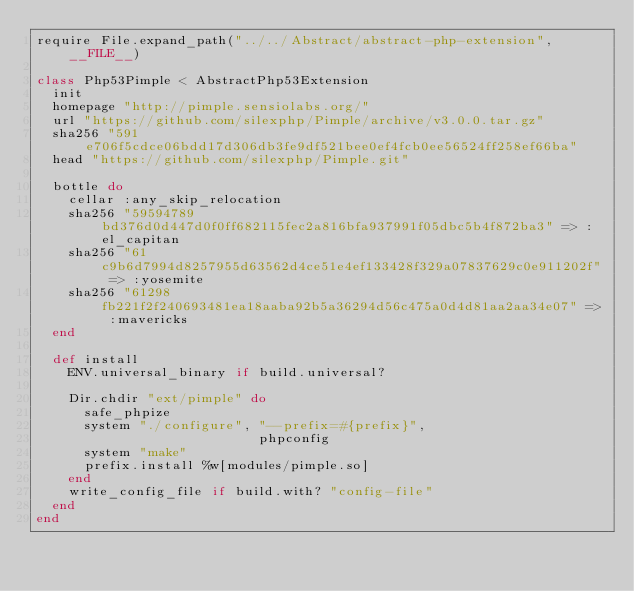<code> <loc_0><loc_0><loc_500><loc_500><_Ruby_>require File.expand_path("../../Abstract/abstract-php-extension", __FILE__)

class Php53Pimple < AbstractPhp53Extension
  init
  homepage "http://pimple.sensiolabs.org/"
  url "https://github.com/silexphp/Pimple/archive/v3.0.0.tar.gz"
  sha256 "591e706f5cdce06bdd17d306db3fe9df521bee0ef4fcb0ee56524ff258ef66ba"
  head "https://github.com/silexphp/Pimple.git"

  bottle do
    cellar :any_skip_relocation
    sha256 "59594789bd376d0d447d0f0ff682115fec2a816bfa937991f05dbc5b4f872ba3" => :el_capitan
    sha256 "61c9b6d7994d8257955d63562d4ce51e4ef133428f329a07837629c0e911202f" => :yosemite
    sha256 "61298fb221f2f240693481ea18aaba92b5a36294d56c475a0d4d81aa2aa34e07" => :mavericks
  end

  def install
    ENV.universal_binary if build.universal?

    Dir.chdir "ext/pimple" do
      safe_phpize
      system "./configure", "--prefix=#{prefix}",
                            phpconfig
      system "make"
      prefix.install %w[modules/pimple.so]
    end
    write_config_file if build.with? "config-file"
  end
end
</code> 